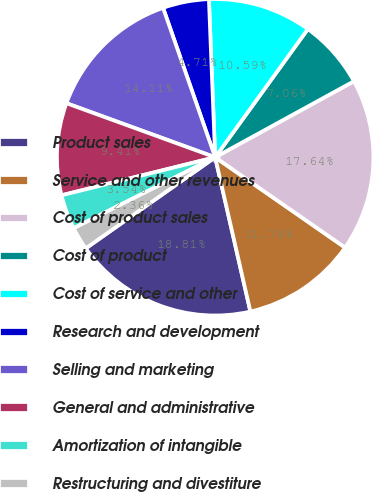<chart> <loc_0><loc_0><loc_500><loc_500><pie_chart><fcel>Product sales<fcel>Service and other revenues<fcel>Cost of product sales<fcel>Cost of product<fcel>Cost of service and other<fcel>Research and development<fcel>Selling and marketing<fcel>General and administrative<fcel>Amortization of intangible<fcel>Restructuring and divestiture<nl><fcel>18.81%<fcel>11.76%<fcel>17.64%<fcel>7.06%<fcel>10.59%<fcel>4.71%<fcel>14.11%<fcel>9.41%<fcel>3.54%<fcel>2.36%<nl></chart> 